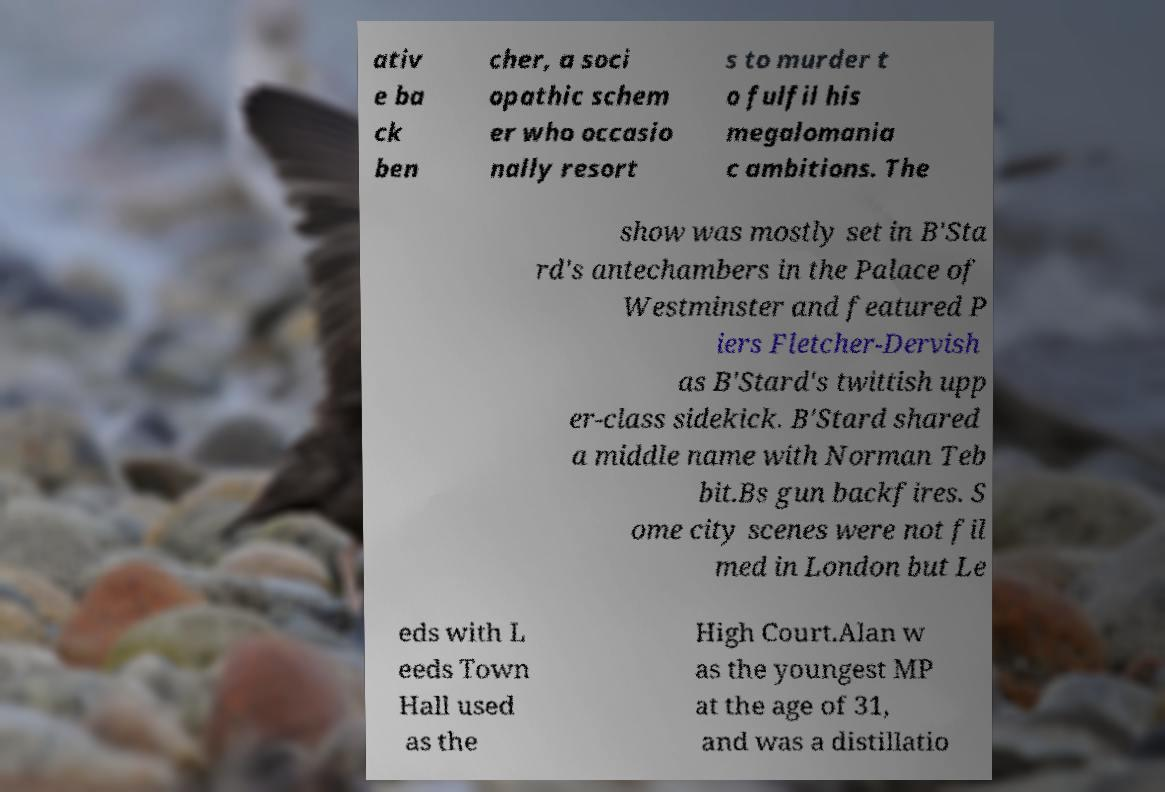Can you read and provide the text displayed in the image?This photo seems to have some interesting text. Can you extract and type it out for me? ativ e ba ck ben cher, a soci opathic schem er who occasio nally resort s to murder t o fulfil his megalomania c ambitions. The show was mostly set in B'Sta rd's antechambers in the Palace of Westminster and featured P iers Fletcher-Dervish as B'Stard's twittish upp er-class sidekick. B'Stard shared a middle name with Norman Teb bit.Bs gun backfires. S ome city scenes were not fil med in London but Le eds with L eeds Town Hall used as the High Court.Alan w as the youngest MP at the age of 31, and was a distillatio 